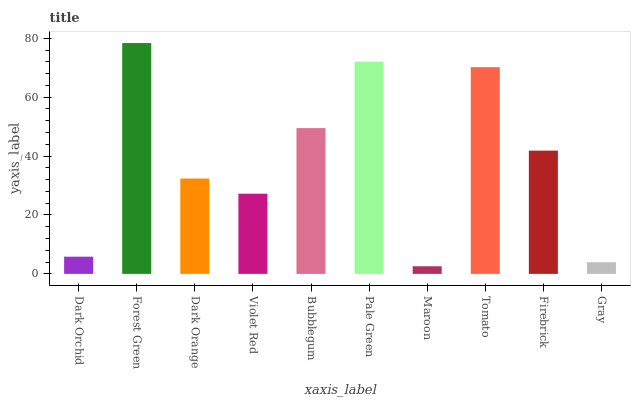Is Dark Orange the minimum?
Answer yes or no. No. Is Dark Orange the maximum?
Answer yes or no. No. Is Forest Green greater than Dark Orange?
Answer yes or no. Yes. Is Dark Orange less than Forest Green?
Answer yes or no. Yes. Is Dark Orange greater than Forest Green?
Answer yes or no. No. Is Forest Green less than Dark Orange?
Answer yes or no. No. Is Firebrick the high median?
Answer yes or no. Yes. Is Dark Orange the low median?
Answer yes or no. Yes. Is Dark Orange the high median?
Answer yes or no. No. Is Forest Green the low median?
Answer yes or no. No. 